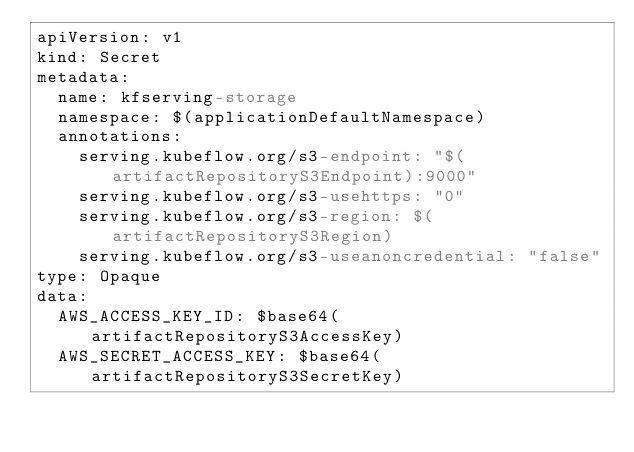Convert code to text. <code><loc_0><loc_0><loc_500><loc_500><_YAML_>apiVersion: v1
kind: Secret
metadata:
  name: kfserving-storage
  namespace: $(applicationDefaultNamespace)
  annotations:
    serving.kubeflow.org/s3-endpoint: "$(artifactRepositoryS3Endpoint):9000"
    serving.kubeflow.org/s3-usehttps: "0"
    serving.kubeflow.org/s3-region: $(artifactRepositoryS3Region)
    serving.kubeflow.org/s3-useanoncredential: "false"
type: Opaque
data:
  AWS_ACCESS_KEY_ID: $base64(artifactRepositoryS3AccessKey)
  AWS_SECRET_ACCESS_KEY: $base64(artifactRepositoryS3SecretKey)
</code> 